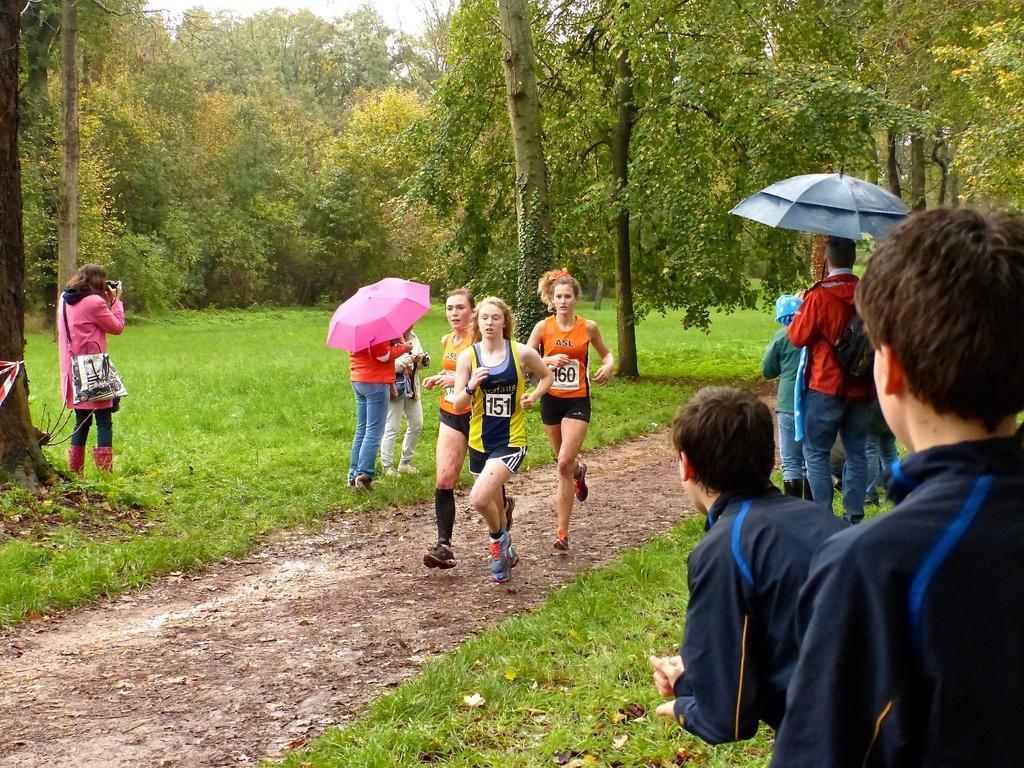Describe this image in one or two sentences. In this image there are women running on the path. People are standing on the grassland. People are standing on the grassland. Few people are holding the umbrellas. Left side there is a woman carrying a bag. She is holding a camera in her hand. Background there are trees. 